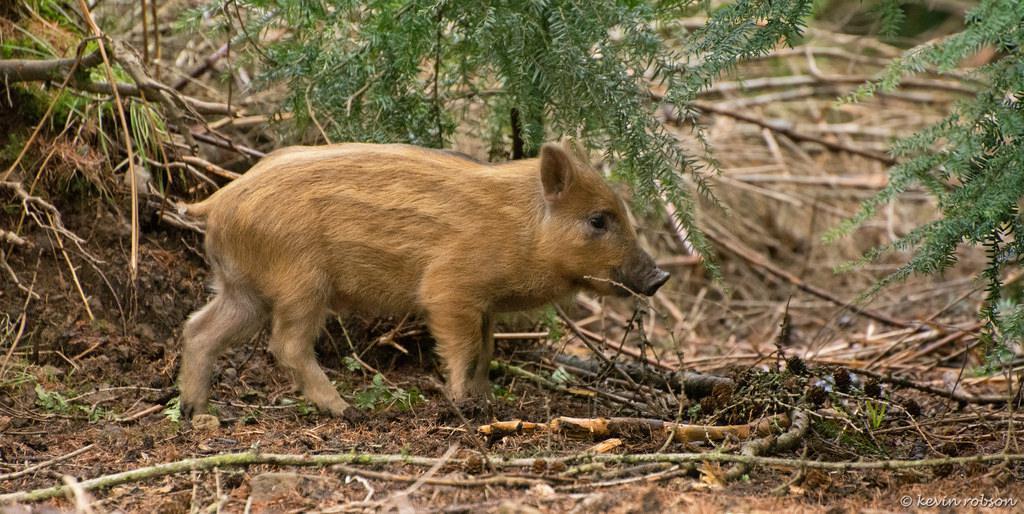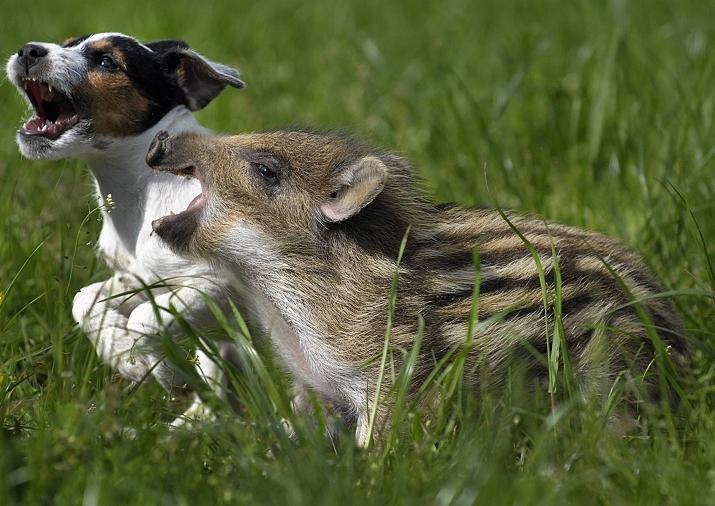The first image is the image on the left, the second image is the image on the right. Considering the images on both sides, is "Both images show the same number of baby warthogs." valid? Answer yes or no. Yes. The first image is the image on the left, the second image is the image on the right. Assess this claim about the two images: "Each image includes at least one piglet with distinctive beige and brown stripes standing in profile on all fours.". Correct or not? Answer yes or no. Yes. 